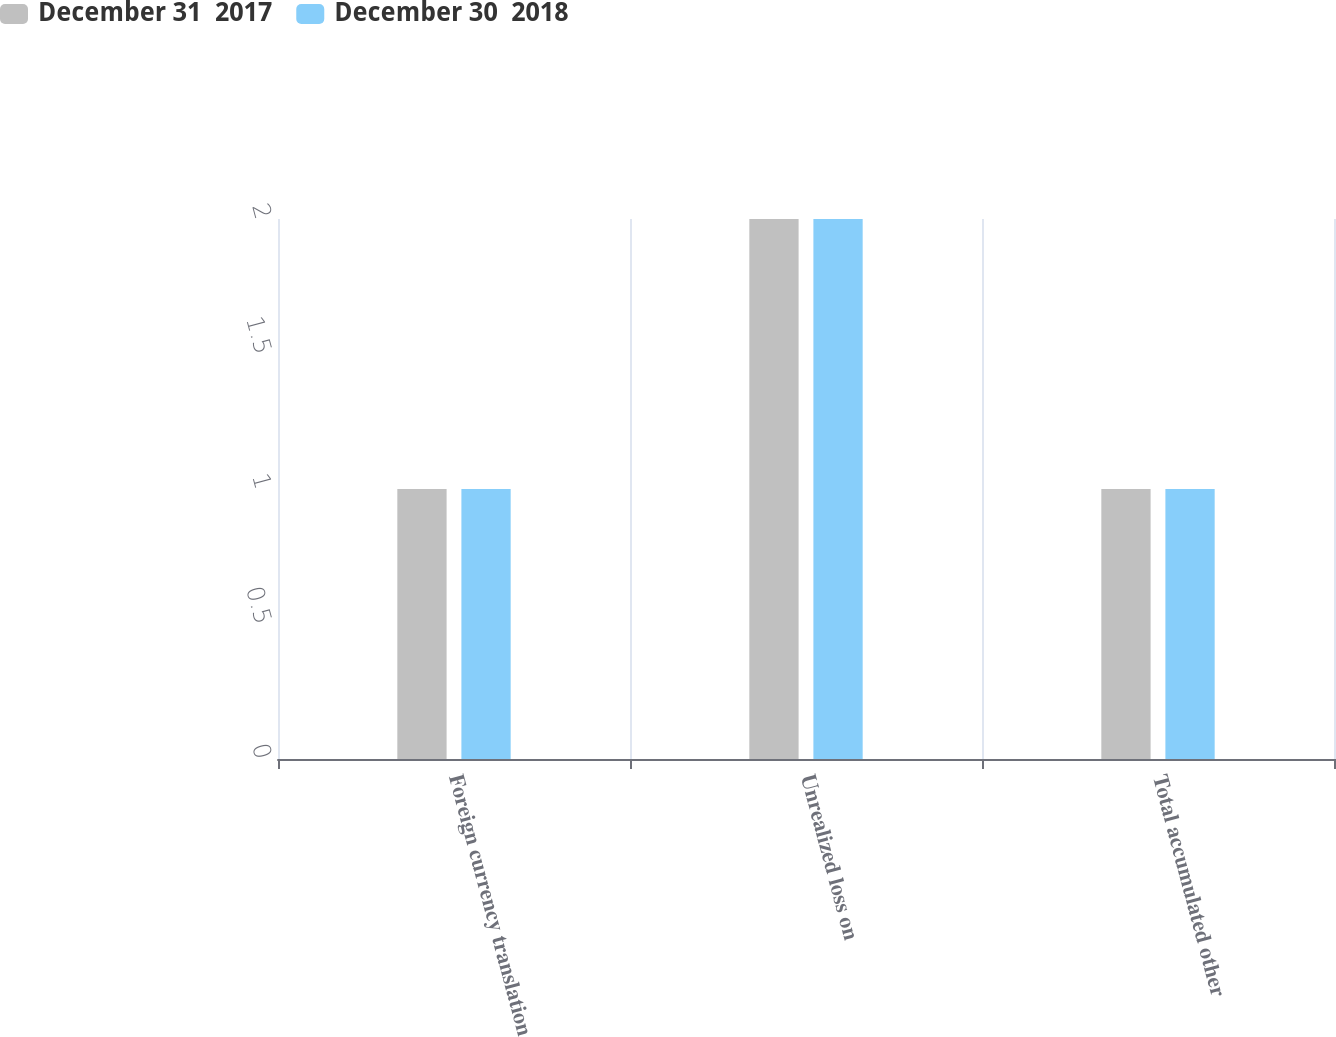Convert chart to OTSL. <chart><loc_0><loc_0><loc_500><loc_500><stacked_bar_chart><ecel><fcel>Foreign currency translation<fcel>Unrealized loss on<fcel>Total accumulated other<nl><fcel>December 31  2017<fcel>1<fcel>2<fcel>1<nl><fcel>December 30  2018<fcel>1<fcel>2<fcel>1<nl></chart> 